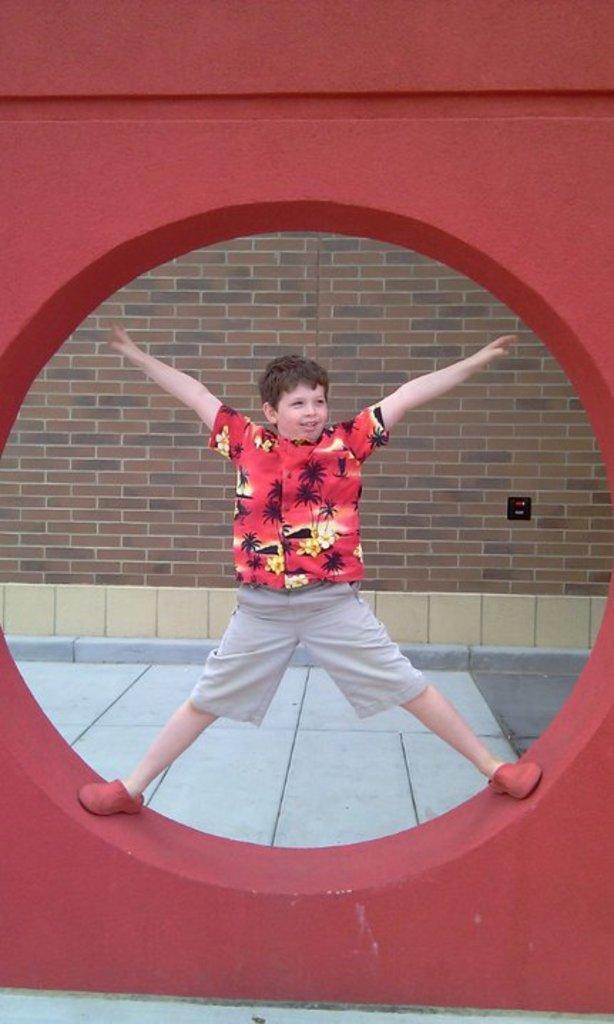Describe this image in one or two sentences. Here in this picture we can see a child stretching his hands and legs and standing in a circle of an architectural structure present over a place and we can see he is smiling. 